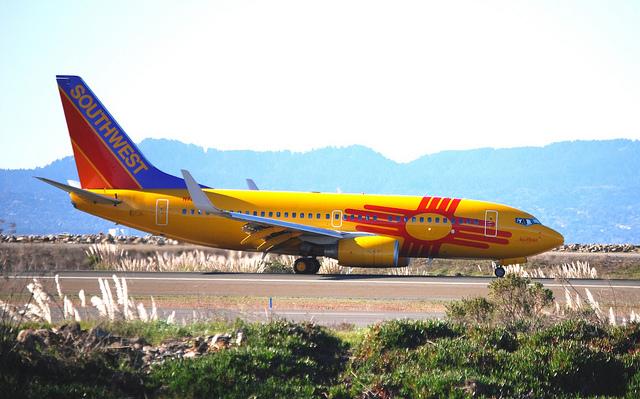What is the main color of the plane?
Quick response, please. Yellow. What is written on the tail of the plane?
Short answer required. Southwest. Where is this?
Quick response, please. Airport. 